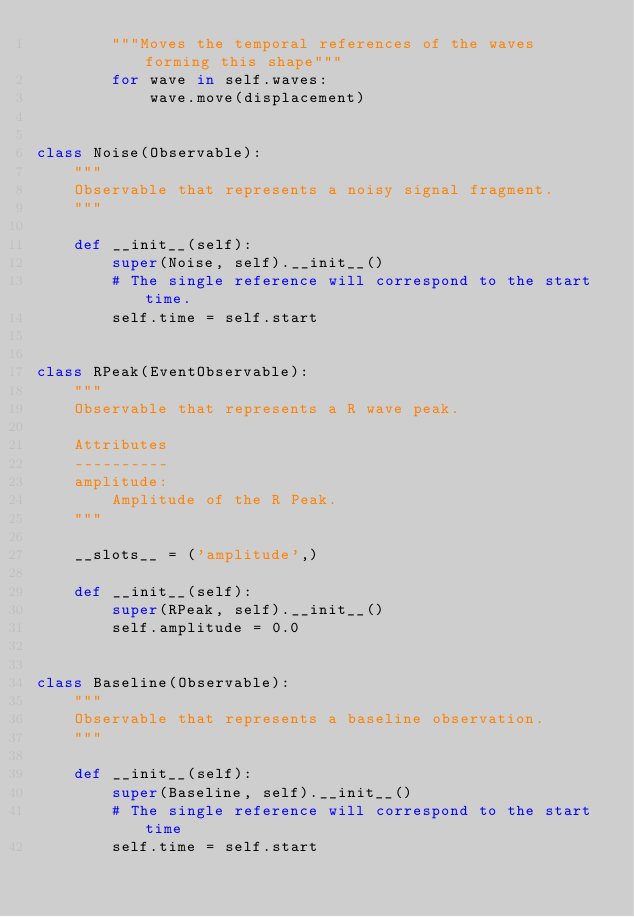<code> <loc_0><loc_0><loc_500><loc_500><_Python_>        """Moves the temporal references of the waves forming this shape"""
        for wave in self.waves:
            wave.move(displacement)


class Noise(Observable):
    """
    Observable that represents a noisy signal fragment.
    """

    def __init__(self):
        super(Noise, self).__init__()
        # The single reference will correspond to the start time.
        self.time = self.start


class RPeak(EventObservable):
    """
    Observable that represents a R wave peak.

    Attributes
    ----------
    amplitude:
        Amplitude of the R Peak.
    """

    __slots__ = ('amplitude',)

    def __init__(self):
        super(RPeak, self).__init__()
        self.amplitude = 0.0


class Baseline(Observable):
    """
    Observable that represents a baseline observation.
    """

    def __init__(self):
        super(Baseline, self).__init__()
        # The single reference will correspond to the start time
        self.time = self.start
</code> 